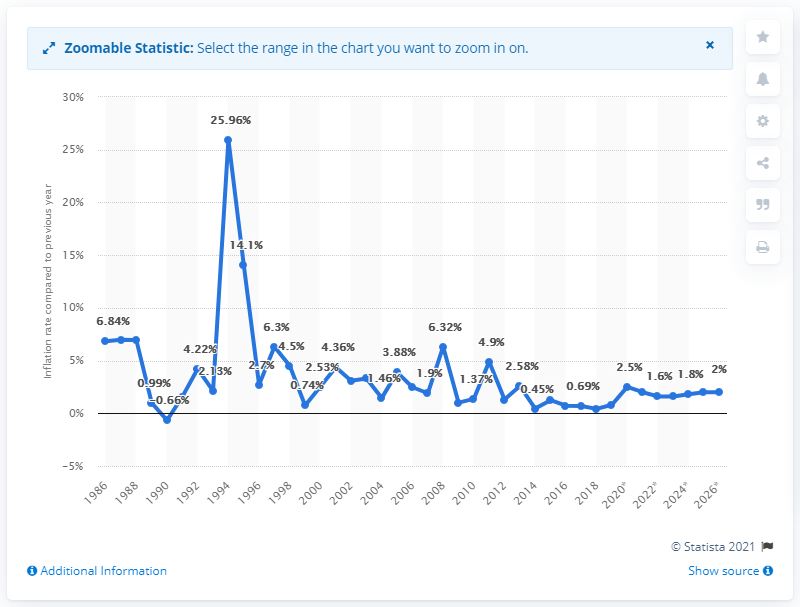Mention a couple of crucial points in this snapshot. The average inflation rate in Ivory Coast was in 1986. 